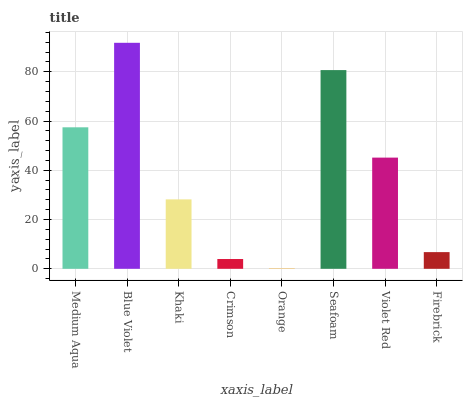Is Khaki the minimum?
Answer yes or no. No. Is Khaki the maximum?
Answer yes or no. No. Is Blue Violet greater than Khaki?
Answer yes or no. Yes. Is Khaki less than Blue Violet?
Answer yes or no. Yes. Is Khaki greater than Blue Violet?
Answer yes or no. No. Is Blue Violet less than Khaki?
Answer yes or no. No. Is Violet Red the high median?
Answer yes or no. Yes. Is Khaki the low median?
Answer yes or no. Yes. Is Crimson the high median?
Answer yes or no. No. Is Seafoam the low median?
Answer yes or no. No. 